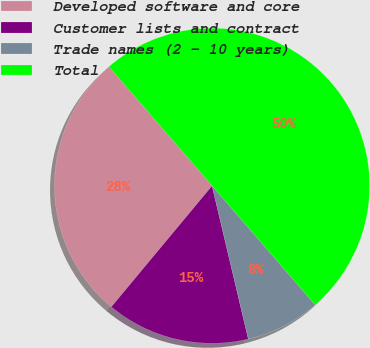Convert chart. <chart><loc_0><loc_0><loc_500><loc_500><pie_chart><fcel>Developed software and core<fcel>Customer lists and contract<fcel>Trade names (2 - 10 years)<fcel>Total<nl><fcel>27.6%<fcel>14.74%<fcel>7.66%<fcel>50.0%<nl></chart> 